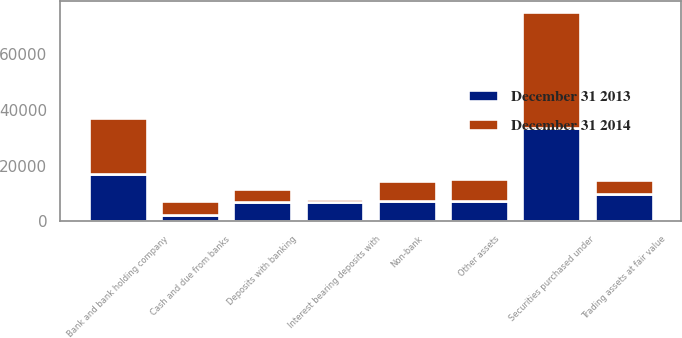<chart> <loc_0><loc_0><loc_500><loc_500><stacked_bar_chart><ecel><fcel>Cash and due from banks<fcel>Deposits with banking<fcel>Interest bearing deposits with<fcel>Trading assets at fair value<fcel>Securities purchased under<fcel>Bank and bank holding company<fcel>Non-bank<fcel>Other assets<nl><fcel>December 31 2014<fcel>5068<fcel>4556<fcel>1126<fcel>5014<fcel>41601<fcel>19982<fcel>7289<fcel>7805<nl><fcel>December 31 2013<fcel>2296<fcel>7070<fcel>6846<fcel>9704<fcel>33748<fcel>17015<fcel>7289<fcel>7508<nl></chart> 